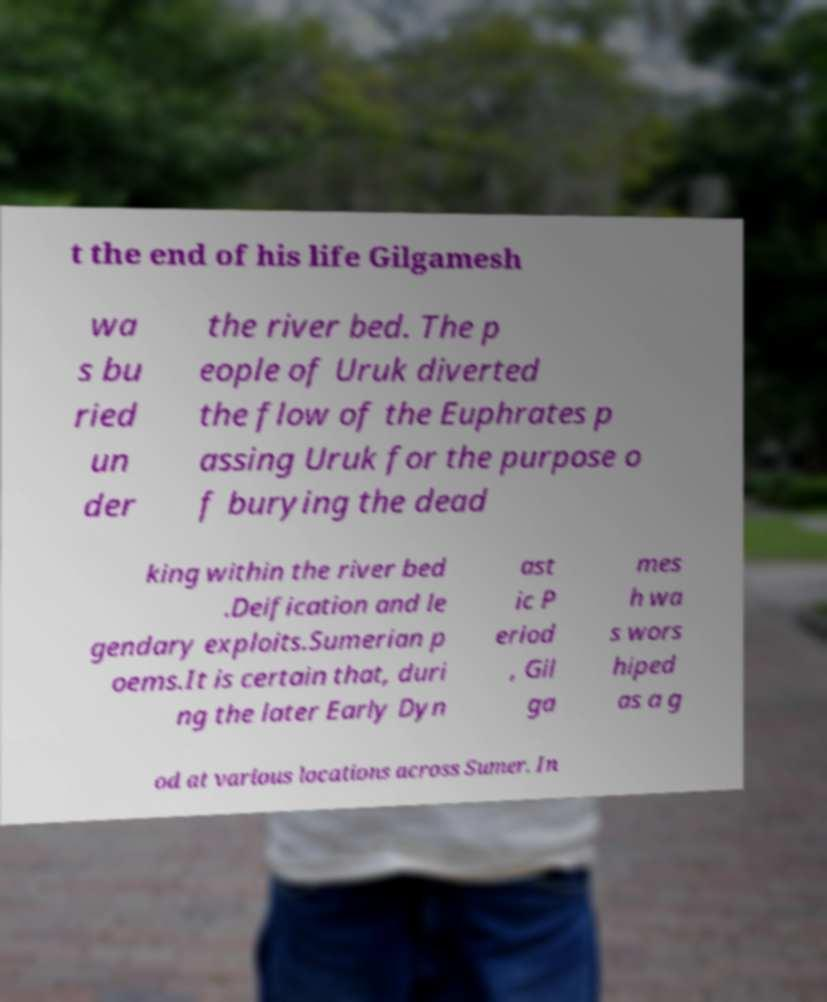Could you assist in decoding the text presented in this image and type it out clearly? t the end of his life Gilgamesh wa s bu ried un der the river bed. The p eople of Uruk diverted the flow of the Euphrates p assing Uruk for the purpose o f burying the dead king within the river bed .Deification and le gendary exploits.Sumerian p oems.It is certain that, duri ng the later Early Dyn ast ic P eriod , Gil ga mes h wa s wors hiped as a g od at various locations across Sumer. In 